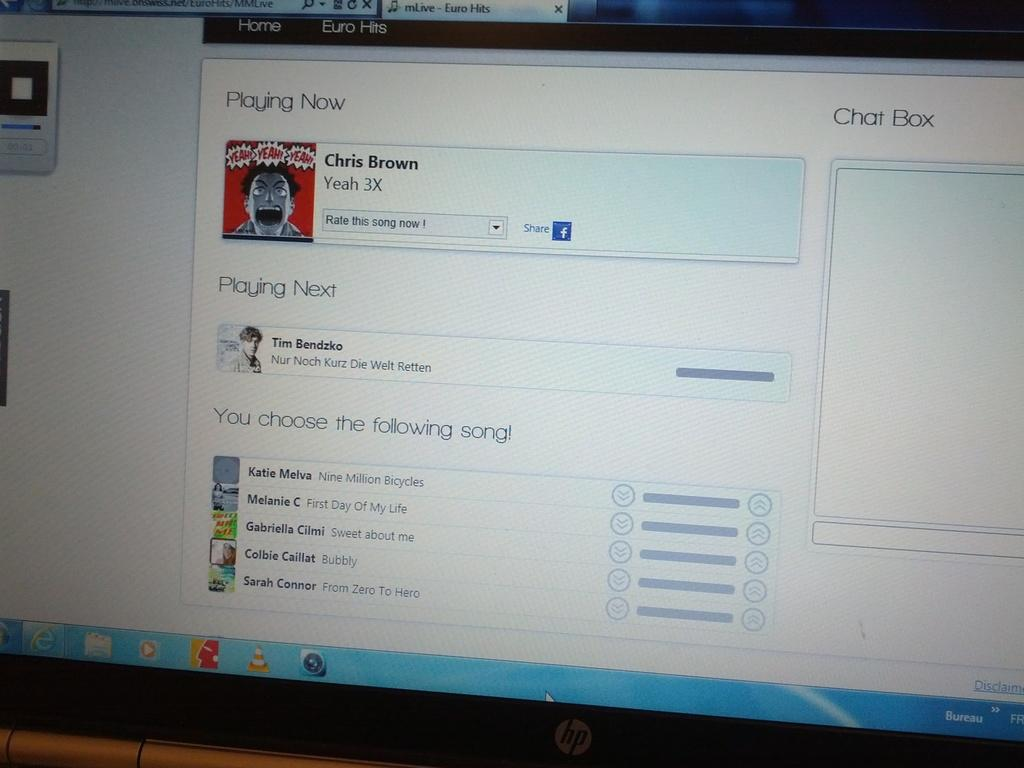<image>
Render a clear and concise summary of the photo. HP computer monitor showing someone listening to a Chris Brown song. 